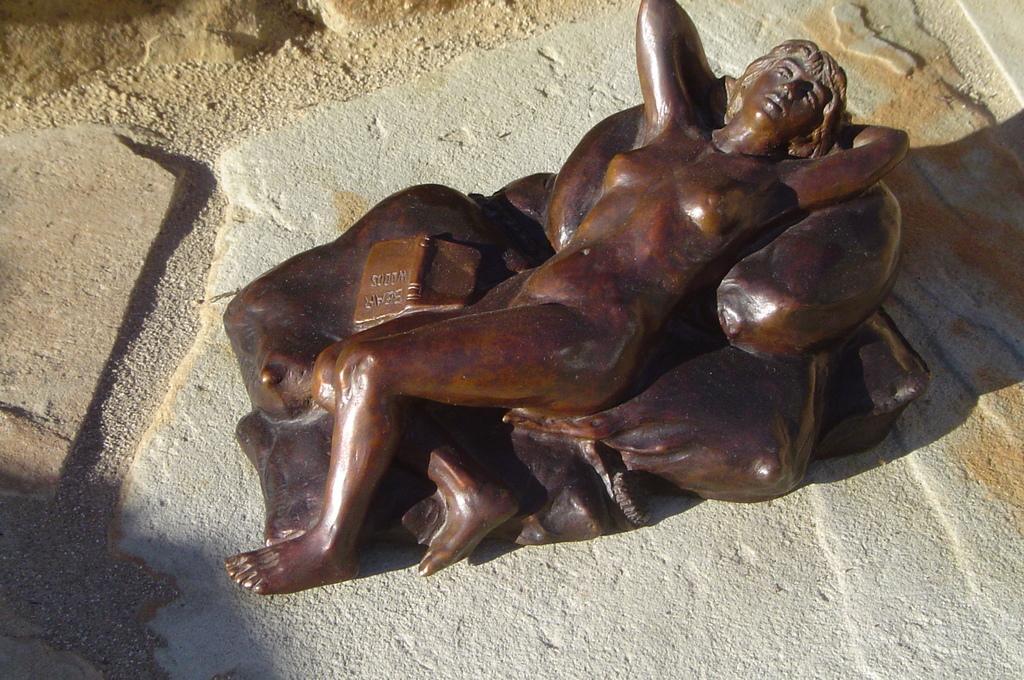How would you summarize this image in a sentence or two? In this picture we can see a sculpture. 